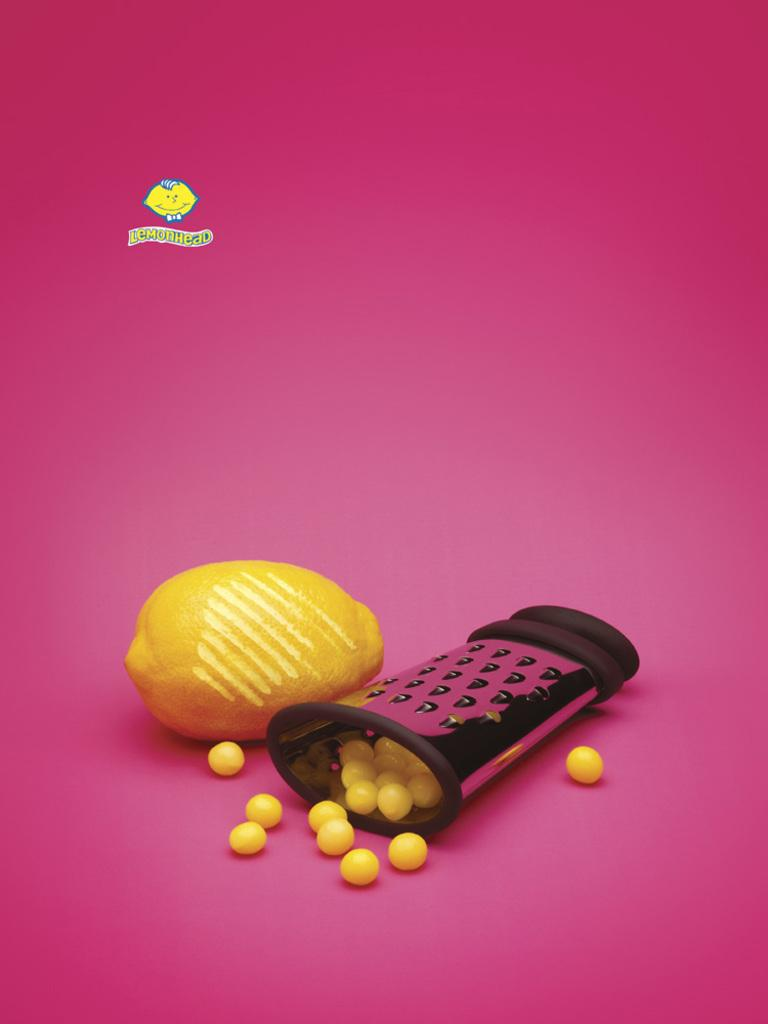What type of fruit is in the image? There is a lemon in the image. What else is present in the image besides the lemon? There are candies and an object in the image. Can you describe the logo at the top of the image? Unfortunately, the facts provided do not give any details about the logo. What is written on the pink surface in the image? There is some text on a pink surface in the image. How many buckets are visible in the image? There are no buckets present in the image. What type of arm is shown holding the lemon in the image? There is no arm visible in the image; it only shows the lemon, candies, and an object. 